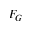<formula> <loc_0><loc_0><loc_500><loc_500>F _ { G }</formula> 